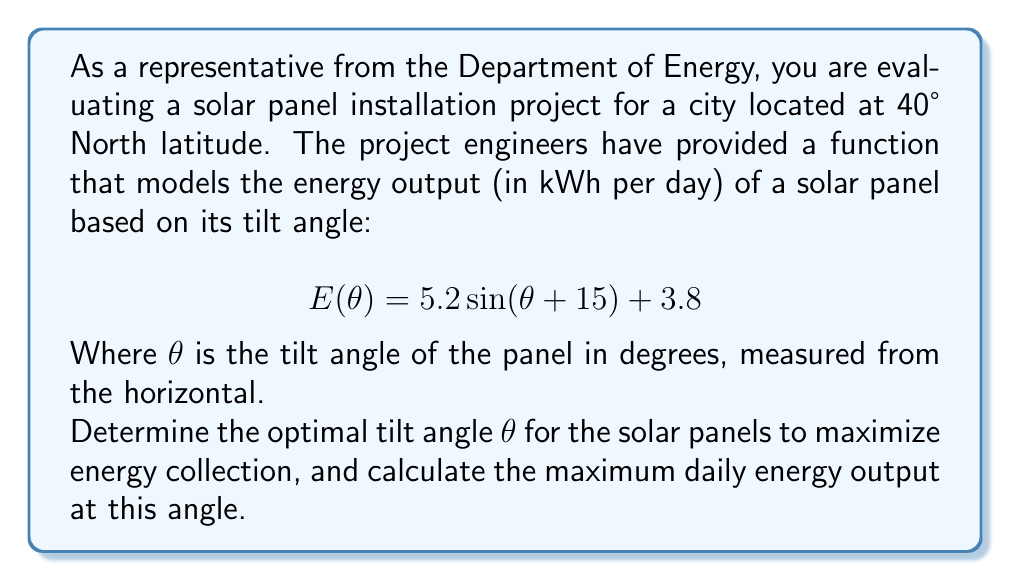What is the answer to this math problem? To solve this problem, we need to find the maximum value of the given function $E(\theta)$. This can be done by finding the value of $\theta$ where the derivative of $E(\theta)$ equals zero.

1) First, let's find the derivative of $E(\theta)$:
   $$E'(\theta) = 5.2 \cos(\theta + 15°)$$

2) Set the derivative equal to zero and solve for $\theta$:
   $$5.2 \cos(\theta + 15°) = 0$$
   $$\cos(\theta + 15°) = 0$$

3) The cosine function equals zero when its argument is 90° or 270°. Since we're dealing with a physical angle, we'll use 90°:
   $$\theta + 15° = 90°$$
   $$\theta = 75°$$

4) To confirm this is a maximum (not a minimum), we can check the second derivative:
   $$E''(\theta) = -5.2 \sin(\theta + 15°)$$
   At $\theta = 75°$, $E''(75°) = -5.2 \sin(90°) = -5.2 < 0$, confirming a maximum.

5) Now that we have the optimal angle, we can calculate the maximum daily energy output by plugging $\theta = 75°$ into the original function:

   $$E(75°) = 5.2 \sin(75° + 15°) + 3.8$$
   $$= 5.2 \sin(90°) + 3.8$$
   $$= 5.2 + 3.8 = 9$$

Therefore, the optimal tilt angle is 75° from the horizontal, and the maximum daily energy output at this angle is 9 kWh.

Note: The optimal angle being 75° for a latitude of 40° N is consistent with the general rule of thumb that optimal tilt is approximately latitude + 15° in winter or latitude - 15° in summer. This model seems to be optimized for winter performance.
Answer: The optimal tilt angle for the solar panels is 75° from the horizontal, and the maximum daily energy output at this angle is 9 kWh. 